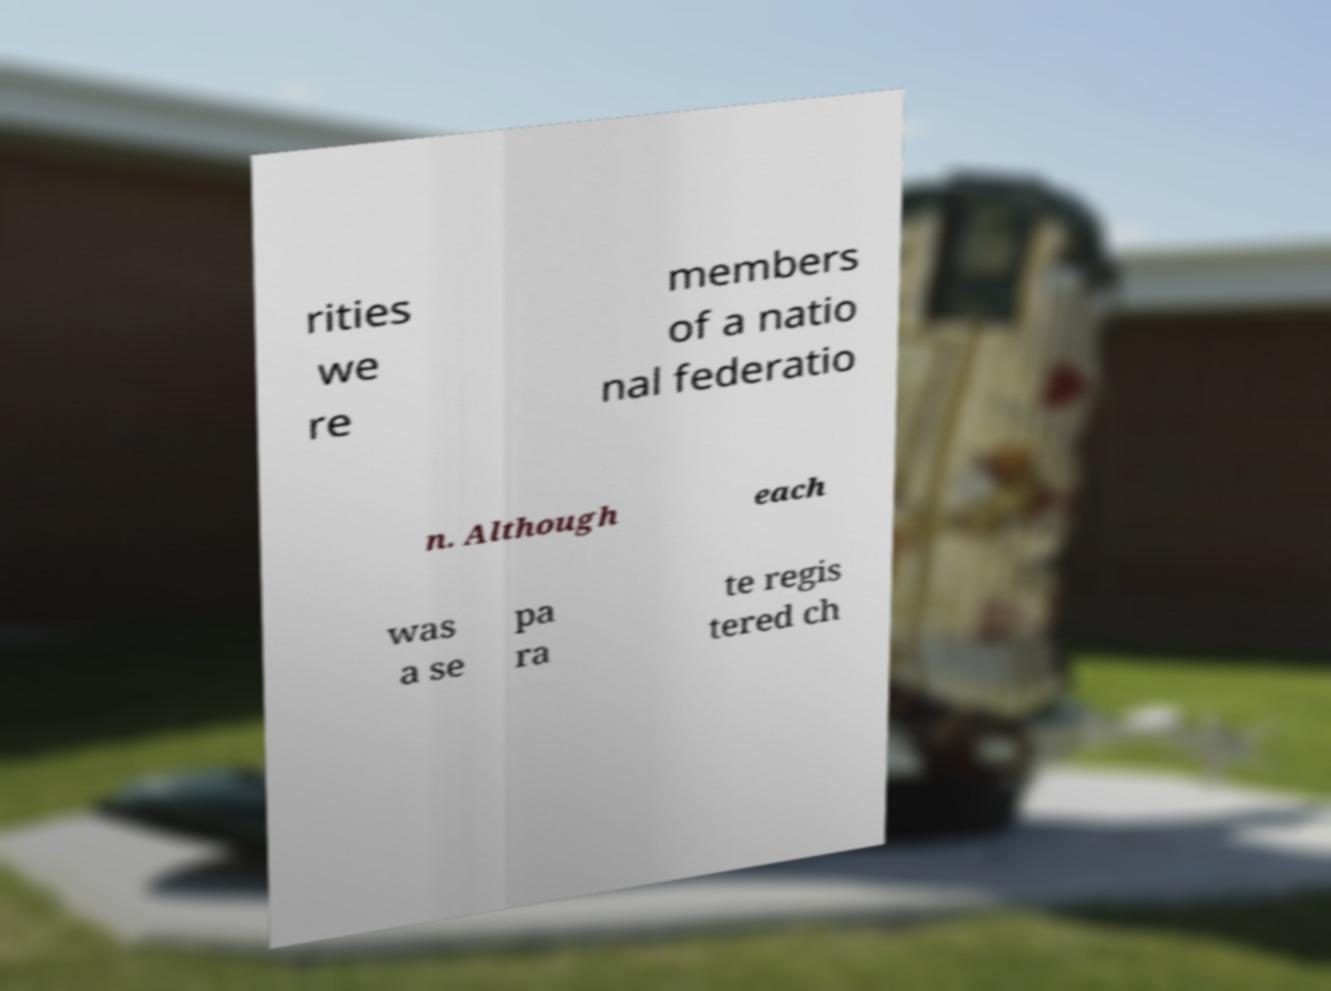Can you accurately transcribe the text from the provided image for me? rities we re members of a natio nal federatio n. Although each was a se pa ra te regis tered ch 